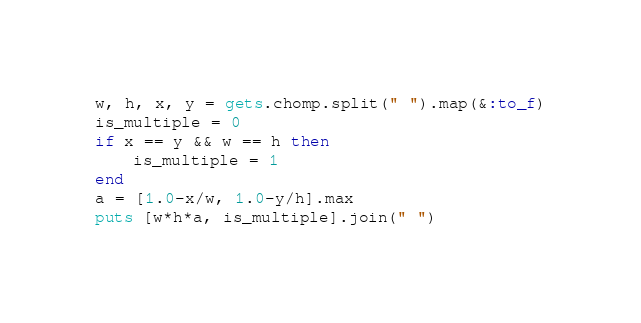Convert code to text. <code><loc_0><loc_0><loc_500><loc_500><_Ruby_>w, h, x, y = gets.chomp.split(" ").map(&:to_f)
is_multiple = 0
if x == y && w == h then
    is_multiple = 1
end
a = [1.0-x/w, 1.0-y/h].max
puts [w*h*a, is_multiple].join(" ")</code> 